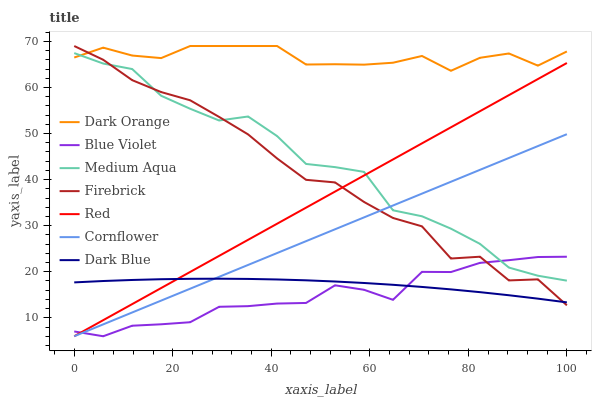Does Blue Violet have the minimum area under the curve?
Answer yes or no. Yes. Does Dark Orange have the maximum area under the curve?
Answer yes or no. Yes. Does Cornflower have the minimum area under the curve?
Answer yes or no. No. Does Cornflower have the maximum area under the curve?
Answer yes or no. No. Is Cornflower the smoothest?
Answer yes or no. Yes. Is Firebrick the roughest?
Answer yes or no. Yes. Is Firebrick the smoothest?
Answer yes or no. No. Is Cornflower the roughest?
Answer yes or no. No. Does Cornflower have the lowest value?
Answer yes or no. Yes. Does Firebrick have the lowest value?
Answer yes or no. No. Does Firebrick have the highest value?
Answer yes or no. Yes. Does Cornflower have the highest value?
Answer yes or no. No. Is Blue Violet less than Dark Orange?
Answer yes or no. Yes. Is Medium Aqua greater than Dark Blue?
Answer yes or no. Yes. Does Blue Violet intersect Cornflower?
Answer yes or no. Yes. Is Blue Violet less than Cornflower?
Answer yes or no. No. Is Blue Violet greater than Cornflower?
Answer yes or no. No. Does Blue Violet intersect Dark Orange?
Answer yes or no. No. 